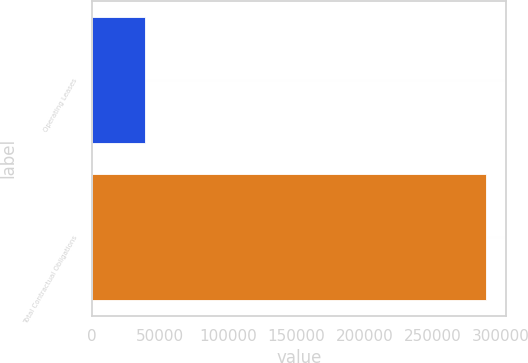Convert chart to OTSL. <chart><loc_0><loc_0><loc_500><loc_500><bar_chart><fcel>Operating Leases<fcel>Total Contractual Obligations<nl><fcel>38886<fcel>289590<nl></chart> 